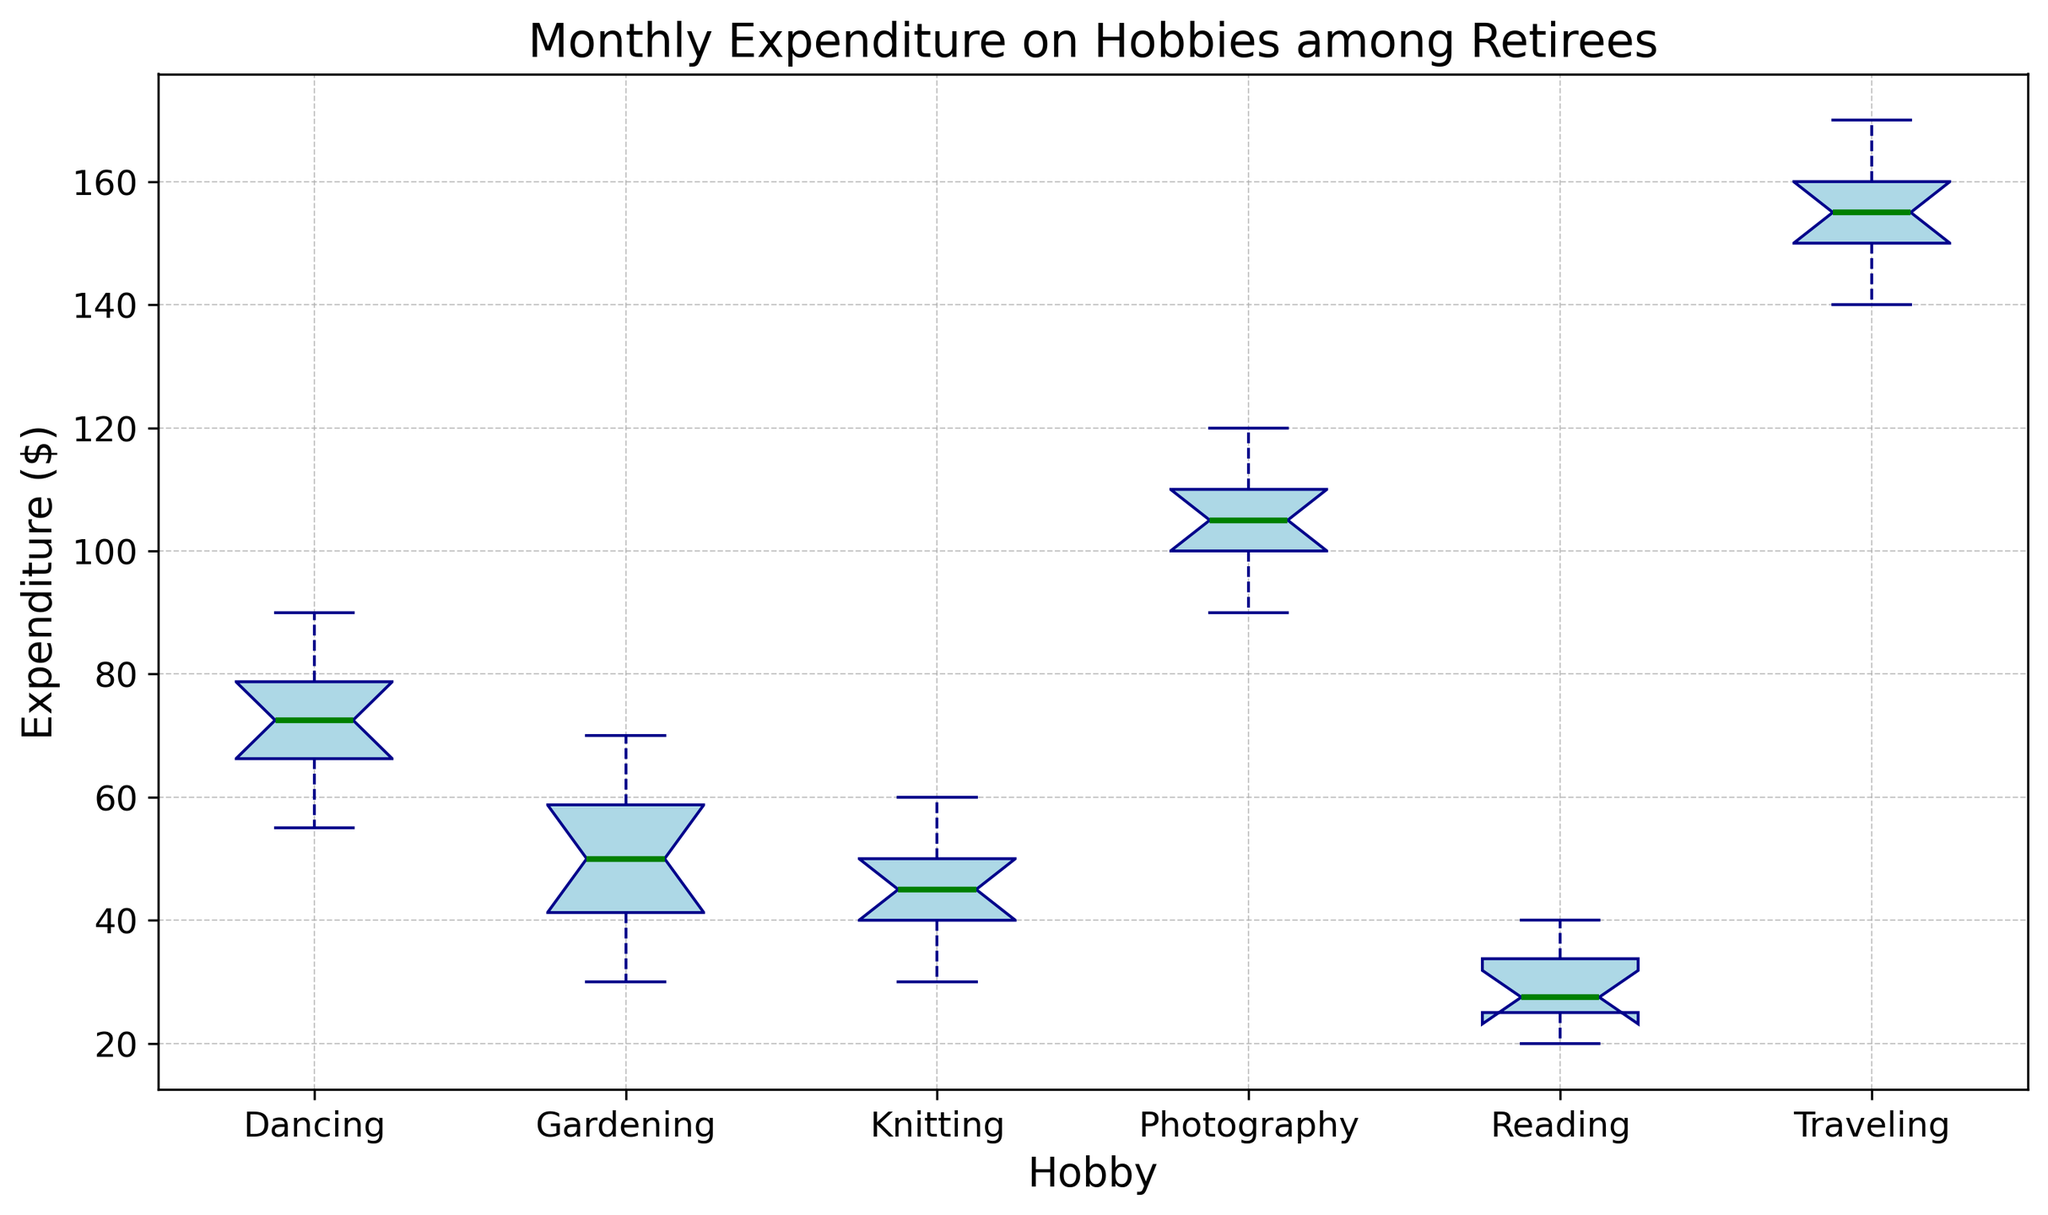What's the median expenditure for Gardening? Look for the middle value in the Gardening box plot. The thick green line inside the Garden’s box represents the median, which is at 50.
Answer: 50 Which hobby has the highest median expenditure? Compare the green lines (medians) across all box plots. Traveling has the highest median expenditure as its median is far above others and around the 155 mark.
Answer: Traveling Between Dancing and Photography, which has a wider interquartile range (IQR)? The IQR is the distance between the lower (25th percentile) and upper (75th percentile) edges of the box. The box for Photography is visually wider compared to Dancing, indicating a larger IQR.
Answer: Photography What's the range of expenditures for Reading? Determine the smallest and largest values by observing the whiskers and potential outliers. For Reading, the expenditure ranges from 20 to 40, giving a range of 20.
Answer: 20 Which hobby has the most variation in monthly expenditure? The variation within a hobby can be visually assessed by the overall height from the bottom whisker to the top whisker. Traveling has the most extended whiskers, showing the highest variation.
Answer: Traveling Is the median expenditure for Knitting greater than or less than Gardening? Compare the positions of the green lines for Knitting and Gardening. The median for both is at the same value of 50.
Answer: Equal to What visual feature indicates an outlier in the box plot? Look for red markers outside the whiskers in the box plot. These points represent outliers.
Answer: Red markers Estimate the upper whisker value for Photography. Observe where the upper whisker ends in the Photography box plot. It looks to be at 120.
Answer: 120 What's the difference between the highest monthly expenditure in Gardening and the highest in Dancing? The highest expenditure in Gardening is at 70, while in Dancing, it is at 90. The difference is 90 - 70 = 20.
Answer: 20 For which hobby is the expenditure most consistently around the median? Look at for the hobby with the smallest overall box height and shortest whiskers, indicating less variation around the median. Reading appears to be more consistent.
Answer: Reading 